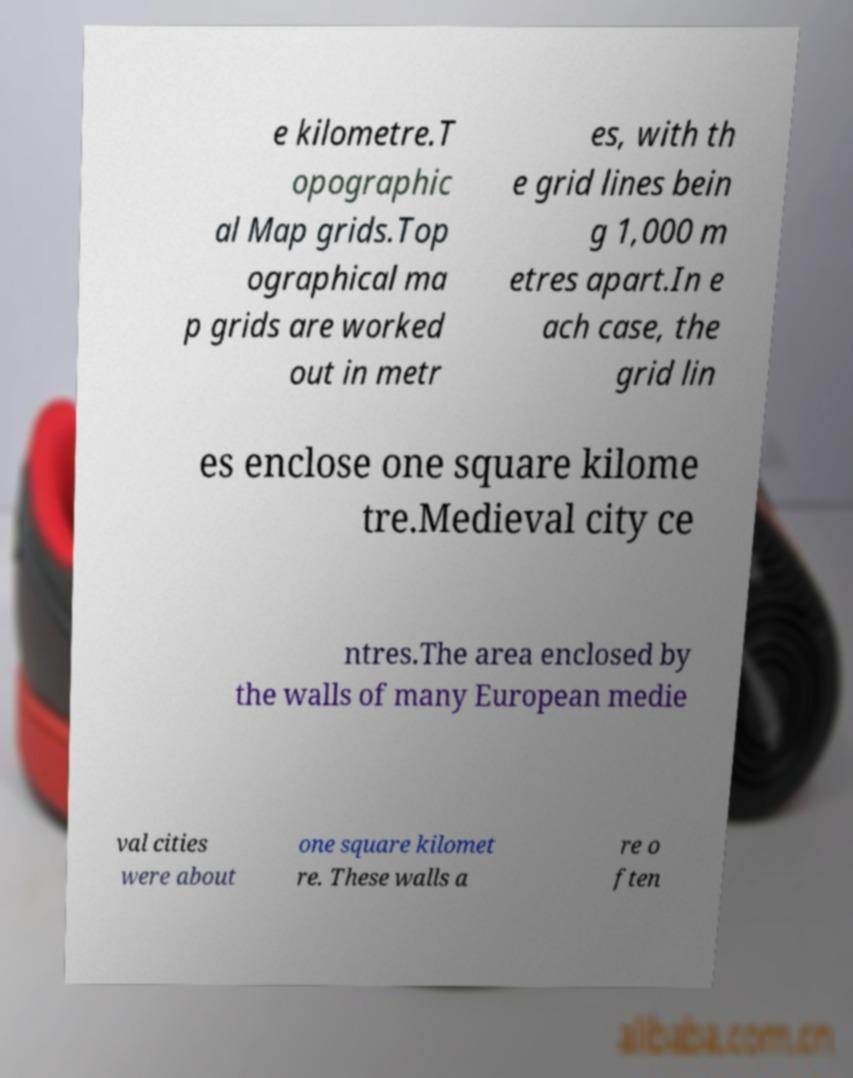What messages or text are displayed in this image? I need them in a readable, typed format. e kilometre.T opographic al Map grids.Top ographical ma p grids are worked out in metr es, with th e grid lines bein g 1,000 m etres apart.In e ach case, the grid lin es enclose one square kilome tre.Medieval city ce ntres.The area enclosed by the walls of many European medie val cities were about one square kilomet re. These walls a re o ften 